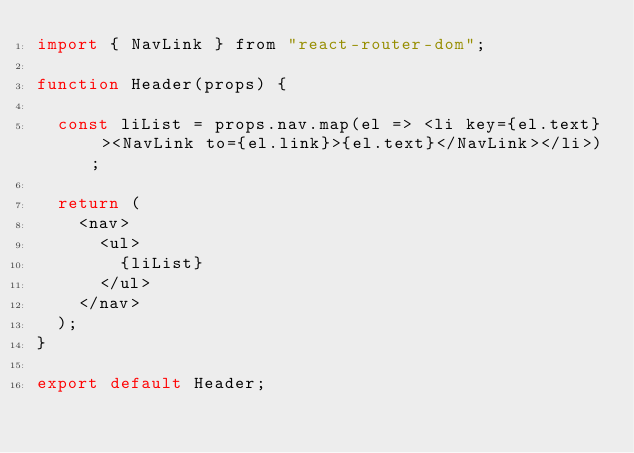Convert code to text. <code><loc_0><loc_0><loc_500><loc_500><_JavaScript_>import { NavLink } from "react-router-dom";

function Header(props) {

  const liList = props.nav.map(el => <li key={el.text} ><NavLink to={el.link}>{el.text}</NavLink></li>);

  return (
    <nav>
      <ul>
        {liList}
      </ul>
    </nav>
  );
}

export default Header;</code> 